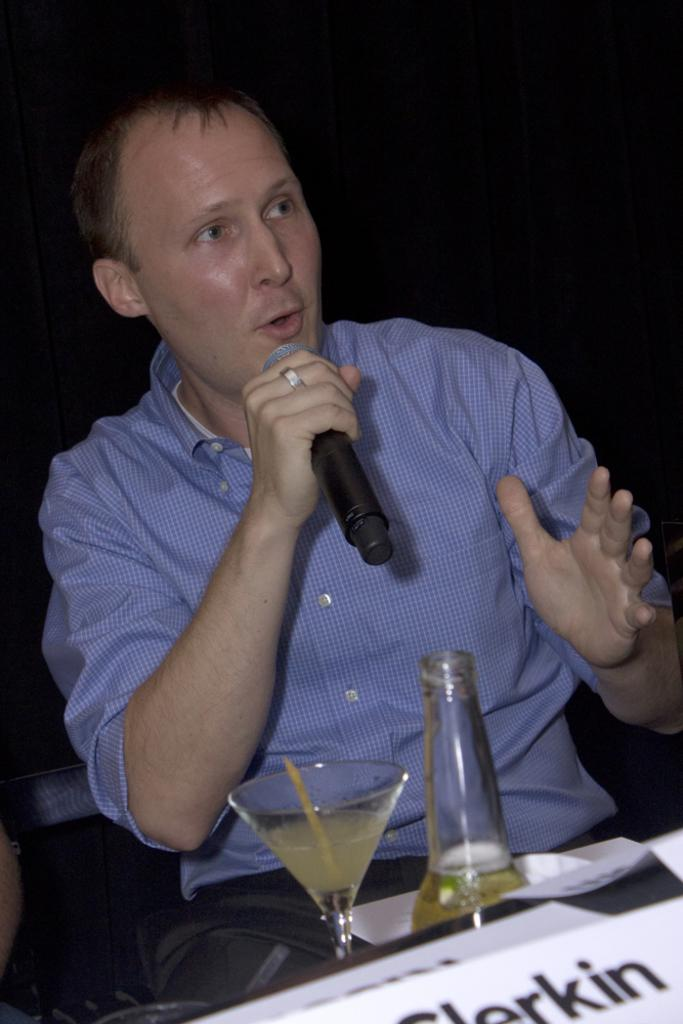What is the man in the image doing? The man is talking on a mike. Can you describe any furniture in the image? Yes, there is a chair in the image. What type of glassware is present in the image? There is a glass in the image. What else can be seen in the image besides the man and the chair? There is a bottle in the image. What type of paste is being used to stick the man to the ground in the image? There is no paste or any indication of the man being stuck to the ground in the image. 